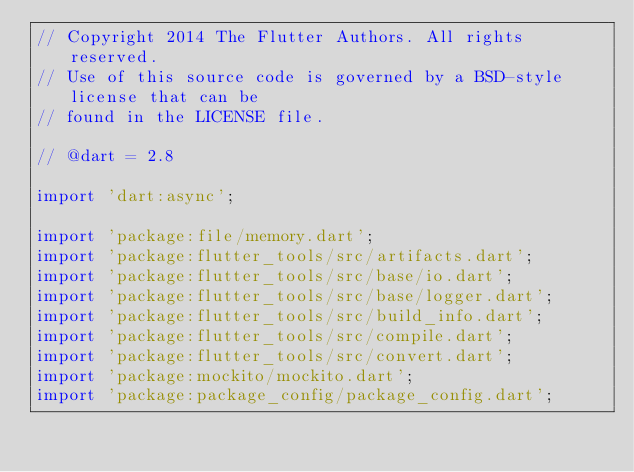<code> <loc_0><loc_0><loc_500><loc_500><_Dart_>// Copyright 2014 The Flutter Authors. All rights reserved.
// Use of this source code is governed by a BSD-style license that can be
// found in the LICENSE file.

// @dart = 2.8

import 'dart:async';

import 'package:file/memory.dart';
import 'package:flutter_tools/src/artifacts.dart';
import 'package:flutter_tools/src/base/io.dart';
import 'package:flutter_tools/src/base/logger.dart';
import 'package:flutter_tools/src/build_info.dart';
import 'package:flutter_tools/src/compile.dart';
import 'package:flutter_tools/src/convert.dart';
import 'package:mockito/mockito.dart';
import 'package:package_config/package_config.dart';</code> 